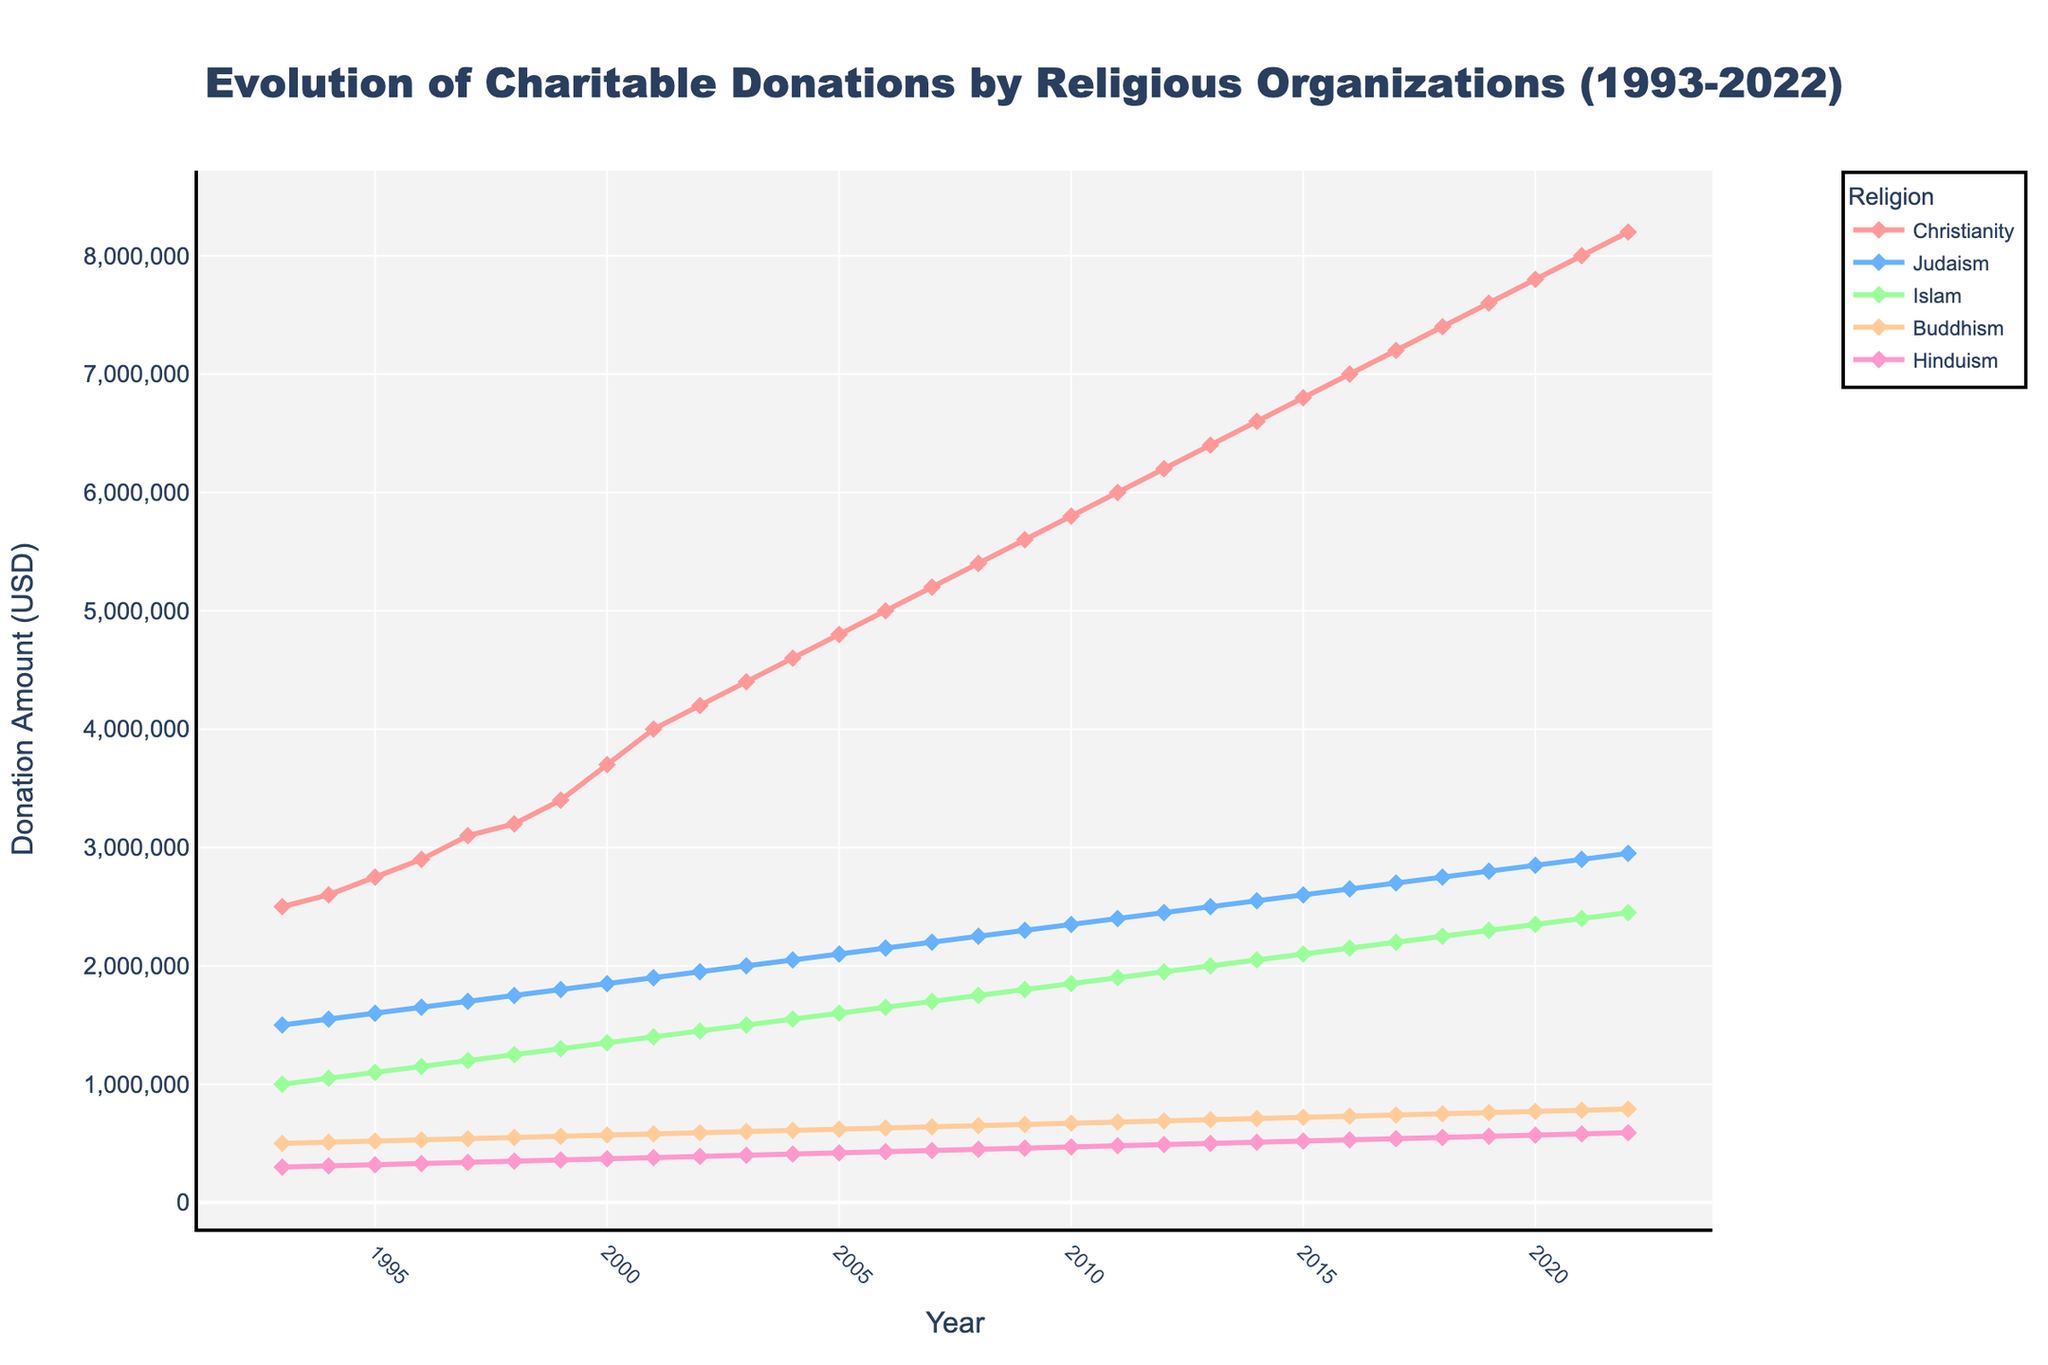When did charitable donations by Christian organizations first exceed 5 million dollars? By observing the curve representing Christianity, we can see it crosses the 5 million dollar mark at the year labeled on the x-axis.
Answer: 2006 Which religious organization received the lowest donation in 1993? By looking at the data points in 1993 for all religions, we find the smallest value.
Answer: Hinduism Compare the trend in donations for Judaism and Islam between 1993 and 2022. Who saw a larger increase? Check the difference in donations from 1993 to 2022 for both religions, then compare these increases. Judaism increase: 2950000 - 1500000 = 1450000, Islam increase: 2450000 - 1000000 = 1450000. The increases are equal.
Answer: Judaism and Islam saw the same increase What is the average annual donation amount for Buddhism from 1993 to 2022? Sum all annual donations for Buddhism from 1993 to 2022, then divide by the number of years (30). Sum = 500000 + 510000 + 520000 + ... + 790000 / 30. Compute to find the average.
Answer: 680000 In which year did Hinduism's donations reach 1 million dollars? Observe the curve for Hinduism to find the x-axis year when donations first reach 1 million.
Answer: Hinduism never reached 1 million Which religion had the greatest donation amount in 2020? Look at the data points for each religion in 2020 to identify the highest value.
Answer: Christianity How many total donations did Islam receive in the entire period from 1993 to 2022? Sum all annual donations for Islam from 1993 to 2022. Sum = 1000000 + 1050000 + 1100000 + ... + 2450000. Compute the total.
Answer: 48700000 Which religion experienced the most consistent (steady) growth in donations over the years? Compare the smoothness and steadiness of each religion's curve in the plot; the most straight and non-fluctuating line indicates consistent growth.
Answer: Christianity What is the total amount of donations given by all religions in the year 2001? Sum the donation amounts for all religions in 2001. Sum = 4000000 + 1900000 + 1400000 + 580000 + 380000.
Answer: 8260000 Between 2010 and 2015, did any religion see a decline in donations? Observe the curves between the years 2010 and 2015 to check for any downward trends.
Answer: No 